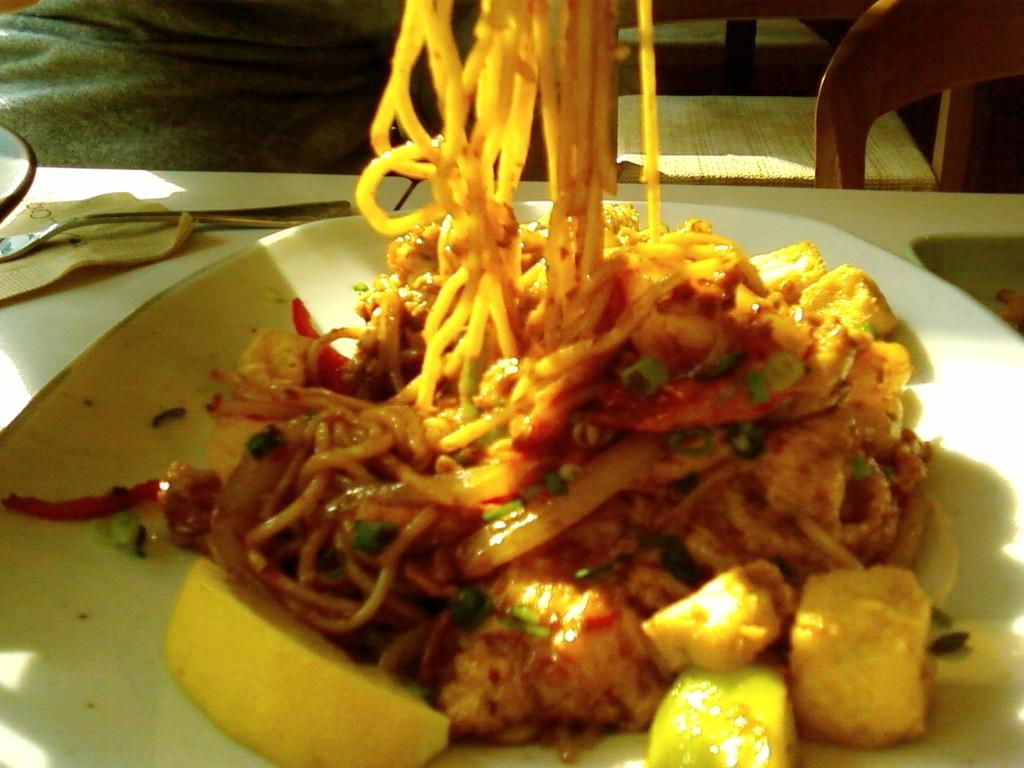Who or what is present in the image? There is a person in the image. What piece of furniture is in the image? There is a chair in the image. What other piece of furniture is in the image? There is a table in the image. What is on the table? There is a plate and a fork on the table. What is in the plate? There are noodles in the plate. What type of quiver is the person holding in the image? There is no quiver present in the image. What kind of brick is visible on the table? There are no bricks present in the image. 